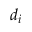Convert formula to latex. <formula><loc_0><loc_0><loc_500><loc_500>d _ { i }</formula> 